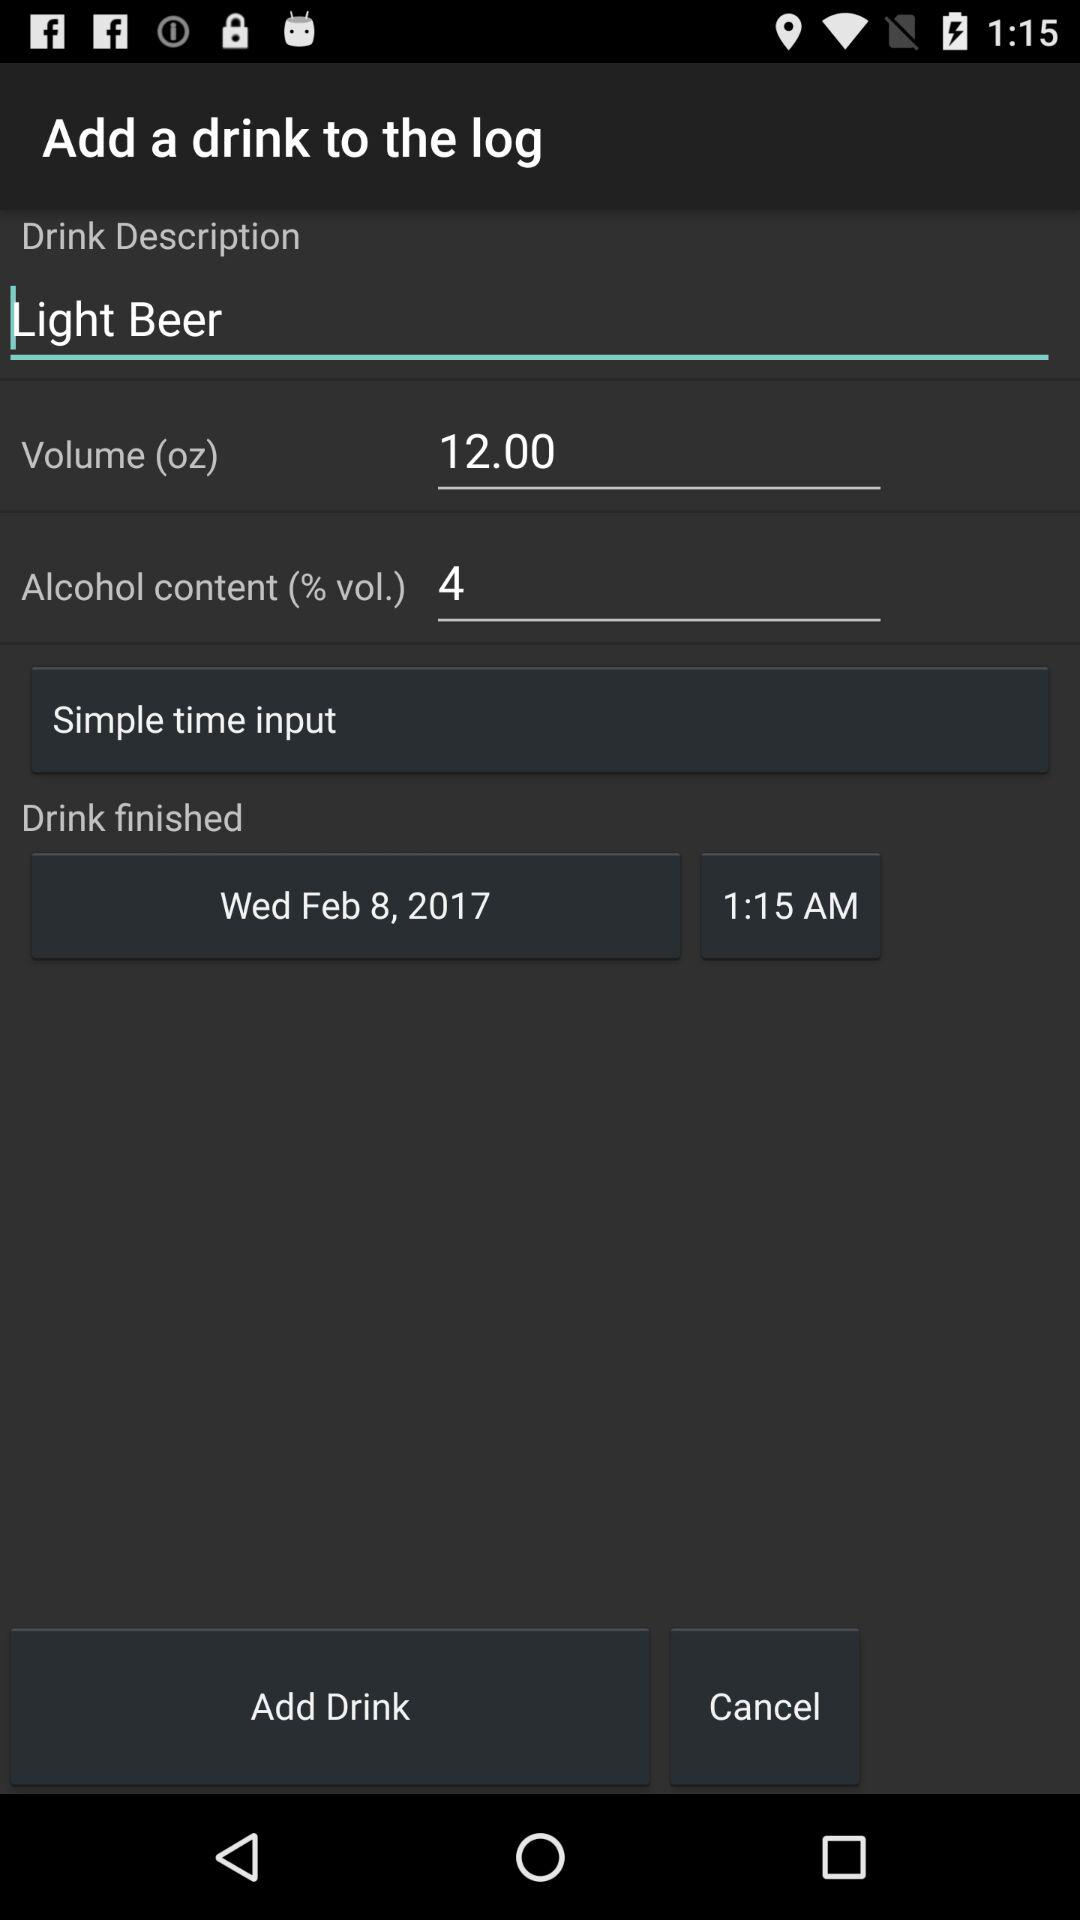What is the alcohol content? The alcohol content is 4%. 